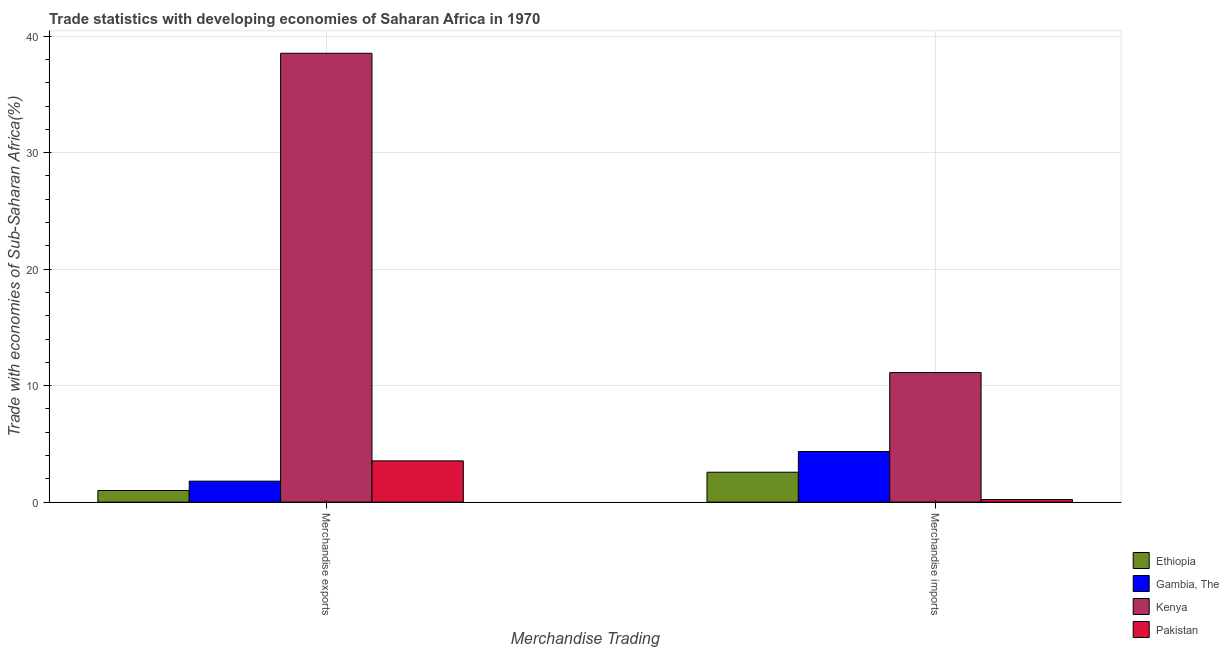How many groups of bars are there?
Offer a terse response. 2. How many bars are there on the 1st tick from the left?
Ensure brevity in your answer.  4. What is the merchandise imports in Ethiopia?
Give a very brief answer. 2.57. Across all countries, what is the maximum merchandise imports?
Your response must be concise. 11.12. Across all countries, what is the minimum merchandise exports?
Give a very brief answer. 1. In which country was the merchandise exports maximum?
Your answer should be very brief. Kenya. In which country was the merchandise imports minimum?
Ensure brevity in your answer.  Pakistan. What is the total merchandise imports in the graph?
Provide a succinct answer. 18.26. What is the difference between the merchandise imports in Ethiopia and that in Gambia, The?
Make the answer very short. -1.78. What is the difference between the merchandise exports in Kenya and the merchandise imports in Ethiopia?
Make the answer very short. 35.96. What is the average merchandise exports per country?
Provide a succinct answer. 11.22. What is the difference between the merchandise exports and merchandise imports in Kenya?
Give a very brief answer. 27.41. In how many countries, is the merchandise imports greater than 20 %?
Give a very brief answer. 0. What is the ratio of the merchandise exports in Kenya to that in Ethiopia?
Your answer should be very brief. 38.67. In how many countries, is the merchandise imports greater than the average merchandise imports taken over all countries?
Provide a short and direct response. 1. What does the 3rd bar from the left in Merchandise exports represents?
Keep it short and to the point. Kenya. How many bars are there?
Your answer should be compact. 8. What is the difference between two consecutive major ticks on the Y-axis?
Ensure brevity in your answer.  10. Does the graph contain any zero values?
Provide a short and direct response. No. Does the graph contain grids?
Your answer should be very brief. Yes. How are the legend labels stacked?
Offer a terse response. Vertical. What is the title of the graph?
Keep it short and to the point. Trade statistics with developing economies of Saharan Africa in 1970. What is the label or title of the X-axis?
Ensure brevity in your answer.  Merchandise Trading. What is the label or title of the Y-axis?
Your response must be concise. Trade with economies of Sub-Saharan Africa(%). What is the Trade with economies of Sub-Saharan Africa(%) in Ethiopia in Merchandise exports?
Your response must be concise. 1. What is the Trade with economies of Sub-Saharan Africa(%) in Gambia, The in Merchandise exports?
Ensure brevity in your answer.  1.8. What is the Trade with economies of Sub-Saharan Africa(%) of Kenya in Merchandise exports?
Ensure brevity in your answer.  38.53. What is the Trade with economies of Sub-Saharan Africa(%) in Pakistan in Merchandise exports?
Offer a terse response. 3.54. What is the Trade with economies of Sub-Saharan Africa(%) in Ethiopia in Merchandise imports?
Make the answer very short. 2.57. What is the Trade with economies of Sub-Saharan Africa(%) of Gambia, The in Merchandise imports?
Your response must be concise. 4.34. What is the Trade with economies of Sub-Saharan Africa(%) of Kenya in Merchandise imports?
Offer a terse response. 11.12. What is the Trade with economies of Sub-Saharan Africa(%) of Pakistan in Merchandise imports?
Your answer should be compact. 0.22. Across all Merchandise Trading, what is the maximum Trade with economies of Sub-Saharan Africa(%) in Ethiopia?
Your answer should be very brief. 2.57. Across all Merchandise Trading, what is the maximum Trade with economies of Sub-Saharan Africa(%) in Gambia, The?
Make the answer very short. 4.34. Across all Merchandise Trading, what is the maximum Trade with economies of Sub-Saharan Africa(%) in Kenya?
Your response must be concise. 38.53. Across all Merchandise Trading, what is the maximum Trade with economies of Sub-Saharan Africa(%) of Pakistan?
Your answer should be compact. 3.54. Across all Merchandise Trading, what is the minimum Trade with economies of Sub-Saharan Africa(%) in Ethiopia?
Offer a very short reply. 1. Across all Merchandise Trading, what is the minimum Trade with economies of Sub-Saharan Africa(%) of Gambia, The?
Provide a succinct answer. 1.8. Across all Merchandise Trading, what is the minimum Trade with economies of Sub-Saharan Africa(%) of Kenya?
Make the answer very short. 11.12. Across all Merchandise Trading, what is the minimum Trade with economies of Sub-Saharan Africa(%) of Pakistan?
Keep it short and to the point. 0.22. What is the total Trade with economies of Sub-Saharan Africa(%) in Ethiopia in the graph?
Provide a succinct answer. 3.56. What is the total Trade with economies of Sub-Saharan Africa(%) of Gambia, The in the graph?
Keep it short and to the point. 6.15. What is the total Trade with economies of Sub-Saharan Africa(%) of Kenya in the graph?
Your answer should be very brief. 49.65. What is the total Trade with economies of Sub-Saharan Africa(%) of Pakistan in the graph?
Provide a short and direct response. 3.77. What is the difference between the Trade with economies of Sub-Saharan Africa(%) in Ethiopia in Merchandise exports and that in Merchandise imports?
Provide a succinct answer. -1.57. What is the difference between the Trade with economies of Sub-Saharan Africa(%) of Gambia, The in Merchandise exports and that in Merchandise imports?
Your response must be concise. -2.54. What is the difference between the Trade with economies of Sub-Saharan Africa(%) in Kenya in Merchandise exports and that in Merchandise imports?
Give a very brief answer. 27.41. What is the difference between the Trade with economies of Sub-Saharan Africa(%) of Pakistan in Merchandise exports and that in Merchandise imports?
Keep it short and to the point. 3.32. What is the difference between the Trade with economies of Sub-Saharan Africa(%) of Ethiopia in Merchandise exports and the Trade with economies of Sub-Saharan Africa(%) of Gambia, The in Merchandise imports?
Provide a short and direct response. -3.35. What is the difference between the Trade with economies of Sub-Saharan Africa(%) in Ethiopia in Merchandise exports and the Trade with economies of Sub-Saharan Africa(%) in Kenya in Merchandise imports?
Provide a short and direct response. -10.12. What is the difference between the Trade with economies of Sub-Saharan Africa(%) of Ethiopia in Merchandise exports and the Trade with economies of Sub-Saharan Africa(%) of Pakistan in Merchandise imports?
Offer a very short reply. 0.77. What is the difference between the Trade with economies of Sub-Saharan Africa(%) in Gambia, The in Merchandise exports and the Trade with economies of Sub-Saharan Africa(%) in Kenya in Merchandise imports?
Offer a very short reply. -9.32. What is the difference between the Trade with economies of Sub-Saharan Africa(%) in Gambia, The in Merchandise exports and the Trade with economies of Sub-Saharan Africa(%) in Pakistan in Merchandise imports?
Ensure brevity in your answer.  1.58. What is the difference between the Trade with economies of Sub-Saharan Africa(%) in Kenya in Merchandise exports and the Trade with economies of Sub-Saharan Africa(%) in Pakistan in Merchandise imports?
Your answer should be very brief. 38.31. What is the average Trade with economies of Sub-Saharan Africa(%) of Ethiopia per Merchandise Trading?
Give a very brief answer. 1.78. What is the average Trade with economies of Sub-Saharan Africa(%) in Gambia, The per Merchandise Trading?
Your response must be concise. 3.07. What is the average Trade with economies of Sub-Saharan Africa(%) in Kenya per Merchandise Trading?
Give a very brief answer. 24.82. What is the average Trade with economies of Sub-Saharan Africa(%) in Pakistan per Merchandise Trading?
Your answer should be very brief. 1.88. What is the difference between the Trade with economies of Sub-Saharan Africa(%) in Ethiopia and Trade with economies of Sub-Saharan Africa(%) in Gambia, The in Merchandise exports?
Provide a succinct answer. -0.8. What is the difference between the Trade with economies of Sub-Saharan Africa(%) of Ethiopia and Trade with economies of Sub-Saharan Africa(%) of Kenya in Merchandise exports?
Your answer should be very brief. -37.53. What is the difference between the Trade with economies of Sub-Saharan Africa(%) of Ethiopia and Trade with economies of Sub-Saharan Africa(%) of Pakistan in Merchandise exports?
Your answer should be compact. -2.54. What is the difference between the Trade with economies of Sub-Saharan Africa(%) in Gambia, The and Trade with economies of Sub-Saharan Africa(%) in Kenya in Merchandise exports?
Keep it short and to the point. -36.73. What is the difference between the Trade with economies of Sub-Saharan Africa(%) of Gambia, The and Trade with economies of Sub-Saharan Africa(%) of Pakistan in Merchandise exports?
Offer a very short reply. -1.74. What is the difference between the Trade with economies of Sub-Saharan Africa(%) of Kenya and Trade with economies of Sub-Saharan Africa(%) of Pakistan in Merchandise exports?
Offer a terse response. 34.99. What is the difference between the Trade with economies of Sub-Saharan Africa(%) in Ethiopia and Trade with economies of Sub-Saharan Africa(%) in Gambia, The in Merchandise imports?
Your response must be concise. -1.78. What is the difference between the Trade with economies of Sub-Saharan Africa(%) in Ethiopia and Trade with economies of Sub-Saharan Africa(%) in Kenya in Merchandise imports?
Your response must be concise. -8.55. What is the difference between the Trade with economies of Sub-Saharan Africa(%) of Ethiopia and Trade with economies of Sub-Saharan Africa(%) of Pakistan in Merchandise imports?
Your answer should be very brief. 2.34. What is the difference between the Trade with economies of Sub-Saharan Africa(%) in Gambia, The and Trade with economies of Sub-Saharan Africa(%) in Kenya in Merchandise imports?
Offer a terse response. -6.77. What is the difference between the Trade with economies of Sub-Saharan Africa(%) in Gambia, The and Trade with economies of Sub-Saharan Africa(%) in Pakistan in Merchandise imports?
Your answer should be compact. 4.12. What is the difference between the Trade with economies of Sub-Saharan Africa(%) in Kenya and Trade with economies of Sub-Saharan Africa(%) in Pakistan in Merchandise imports?
Give a very brief answer. 10.9. What is the ratio of the Trade with economies of Sub-Saharan Africa(%) in Ethiopia in Merchandise exports to that in Merchandise imports?
Provide a succinct answer. 0.39. What is the ratio of the Trade with economies of Sub-Saharan Africa(%) in Gambia, The in Merchandise exports to that in Merchandise imports?
Provide a short and direct response. 0.41. What is the ratio of the Trade with economies of Sub-Saharan Africa(%) in Kenya in Merchandise exports to that in Merchandise imports?
Offer a very short reply. 3.47. What is the ratio of the Trade with economies of Sub-Saharan Africa(%) of Pakistan in Merchandise exports to that in Merchandise imports?
Offer a very short reply. 15.8. What is the difference between the highest and the second highest Trade with economies of Sub-Saharan Africa(%) in Ethiopia?
Offer a terse response. 1.57. What is the difference between the highest and the second highest Trade with economies of Sub-Saharan Africa(%) of Gambia, The?
Ensure brevity in your answer.  2.54. What is the difference between the highest and the second highest Trade with economies of Sub-Saharan Africa(%) of Kenya?
Offer a very short reply. 27.41. What is the difference between the highest and the second highest Trade with economies of Sub-Saharan Africa(%) of Pakistan?
Offer a very short reply. 3.32. What is the difference between the highest and the lowest Trade with economies of Sub-Saharan Africa(%) in Ethiopia?
Make the answer very short. 1.57. What is the difference between the highest and the lowest Trade with economies of Sub-Saharan Africa(%) in Gambia, The?
Give a very brief answer. 2.54. What is the difference between the highest and the lowest Trade with economies of Sub-Saharan Africa(%) of Kenya?
Give a very brief answer. 27.41. What is the difference between the highest and the lowest Trade with economies of Sub-Saharan Africa(%) of Pakistan?
Your response must be concise. 3.32. 